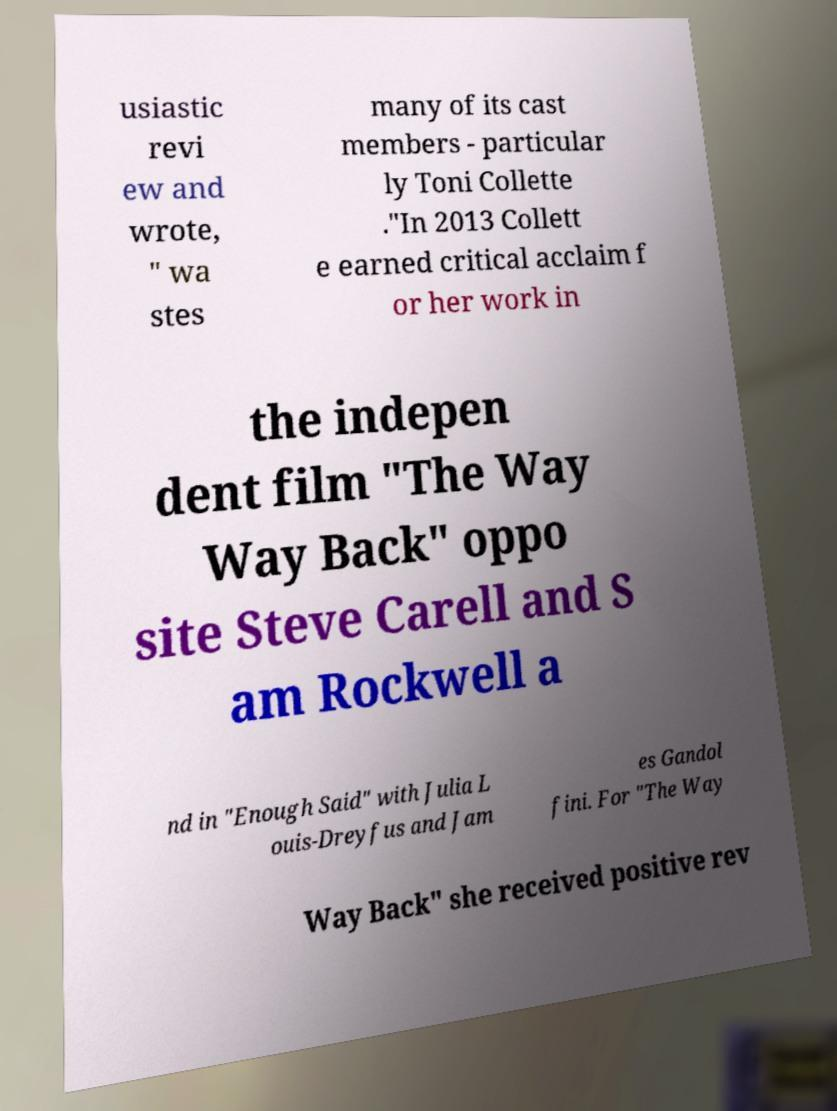I need the written content from this picture converted into text. Can you do that? usiastic revi ew and wrote, " wa stes many of its cast members - particular ly Toni Collette ."In 2013 Collett e earned critical acclaim f or her work in the indepen dent film "The Way Way Back" oppo site Steve Carell and S am Rockwell a nd in "Enough Said" with Julia L ouis-Dreyfus and Jam es Gandol fini. For "The Way Way Back" she received positive rev 